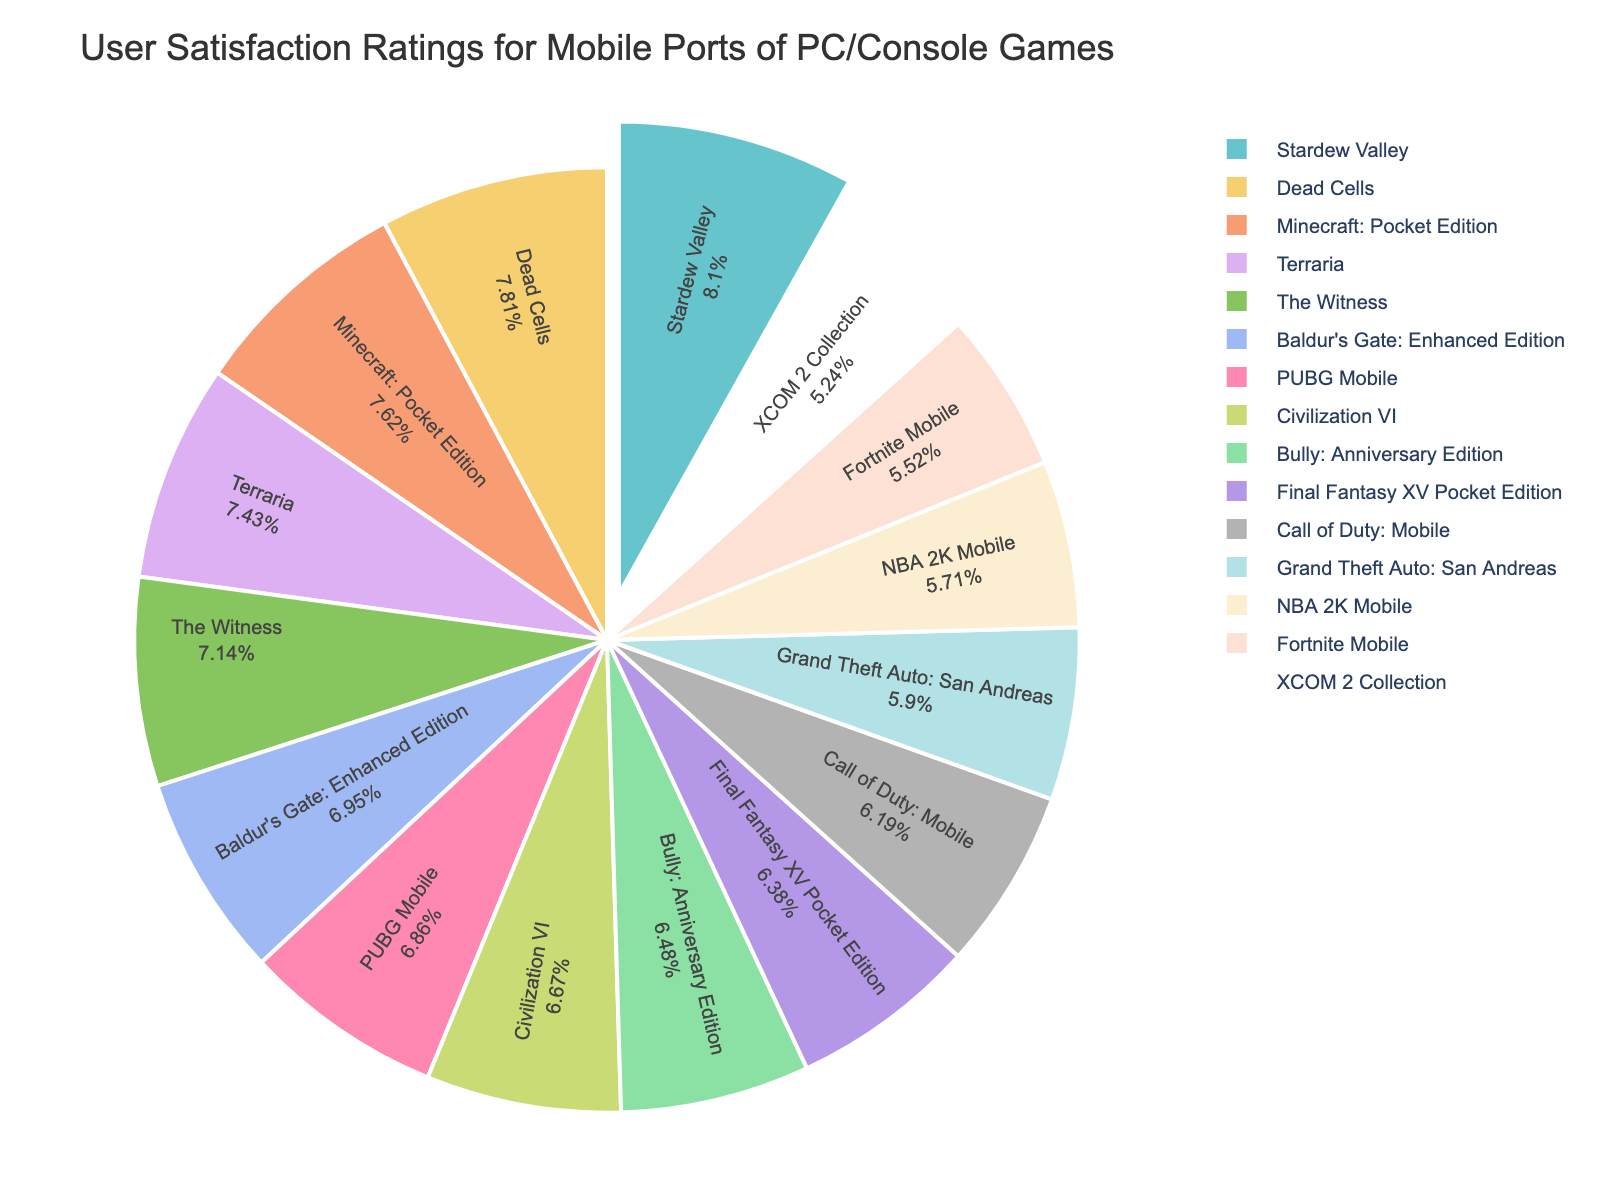Which game has the highest user satisfaction rating? The figure will show a pie chart with percentage labels for each game. The game with the highest percentage is the one with the highest satisfaction rating.
Answer: Stardew Valley Which game has a higher user satisfaction rating: NBA 2K Mobile or Bully: Anniversary Edition? By comparing the two segments of the pie chart labeled NBA 2K Mobile and Bully: Anniversary Edition, check which segment represents a higher percentage.
Answer: Bully: Anniversary Edition What is the combined user satisfaction rating for Dead Cells and Baldur's Gate: Enhanced Edition? Find the pie segments for Dead Cells and Baldur's Gate: Enhanced Edition and add their ratings: 82 + 73 = 155.
Answer: 155 Which game has the lowest user satisfaction rating? Look for the segment in the pie chart with the smallest percentage of the total. This segment represents the game with the lowest user satisfaction rating.
Answer: XCOM 2 Collection How much higher is the user satisfaction rating of Minecraft: Pocket Edition compared to Fortnite Mobile? Subtract the rating of Fortnite Mobile from Minecraft: Pocket Edition: 80 - 58 = 22.
Answer: 22 Which game appears to be more popular in terms of satisfaction: Call of Duty: Mobile or Civilization VI? Compare the two segments representing Call of Duty: Mobile and Civilization VI, and note which one has the higher percentage.
Answer: Civilization VI How many games have a user satisfaction rating higher than 70? Identify the segments with satisfaction ratings above 70 (PUBG Mobile, Minecraft: Pocket Edition, Stardew Valley, The Witness, Terraria, Dead Cells, Baldur's Gate: Enhanced Edition) and count them.
Answer: 7 What is the average user satisfaction rating for the games with ratings above 75? Identify the games above 75 (Minecraft: Pocket Edition, Stardew Valley, The Witness, Terraria, Dead Cells), sum their ratings (80 + 85 + 75 + 78 + 82 = 400), and divide by the number of games (5): 400/5 = 80.
Answer: 80 